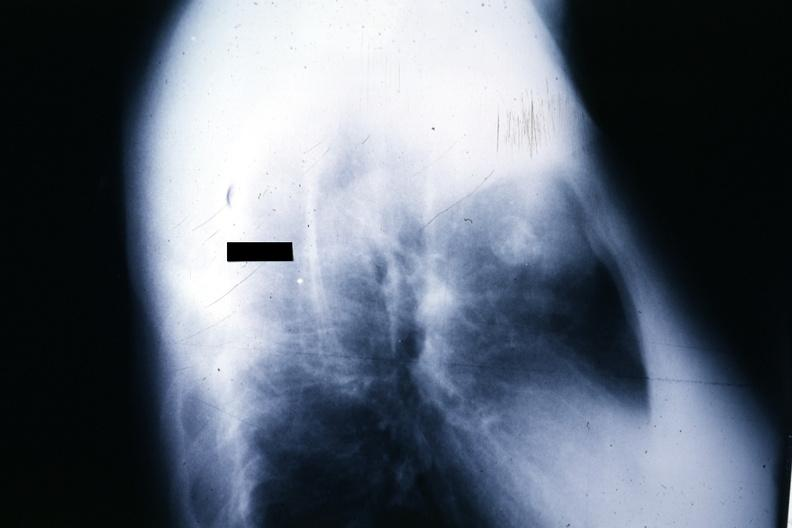what is present?
Answer the question using a single word or phrase. Hematologic 